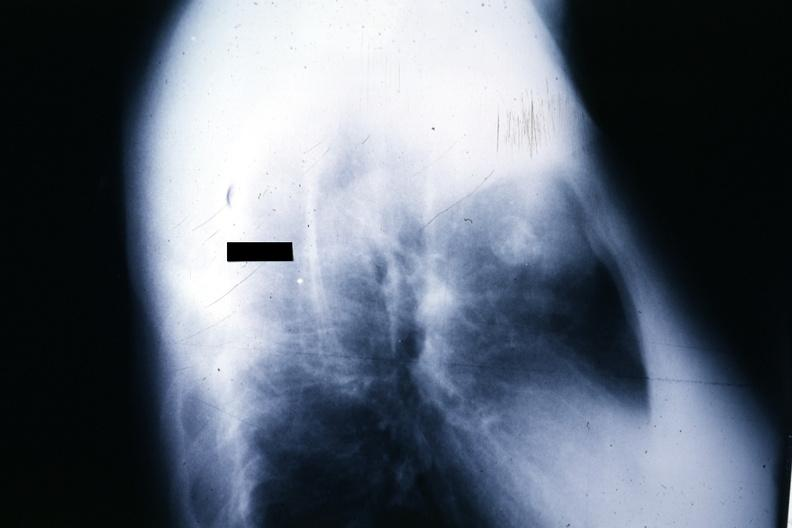what is present?
Answer the question using a single word or phrase. Hematologic 